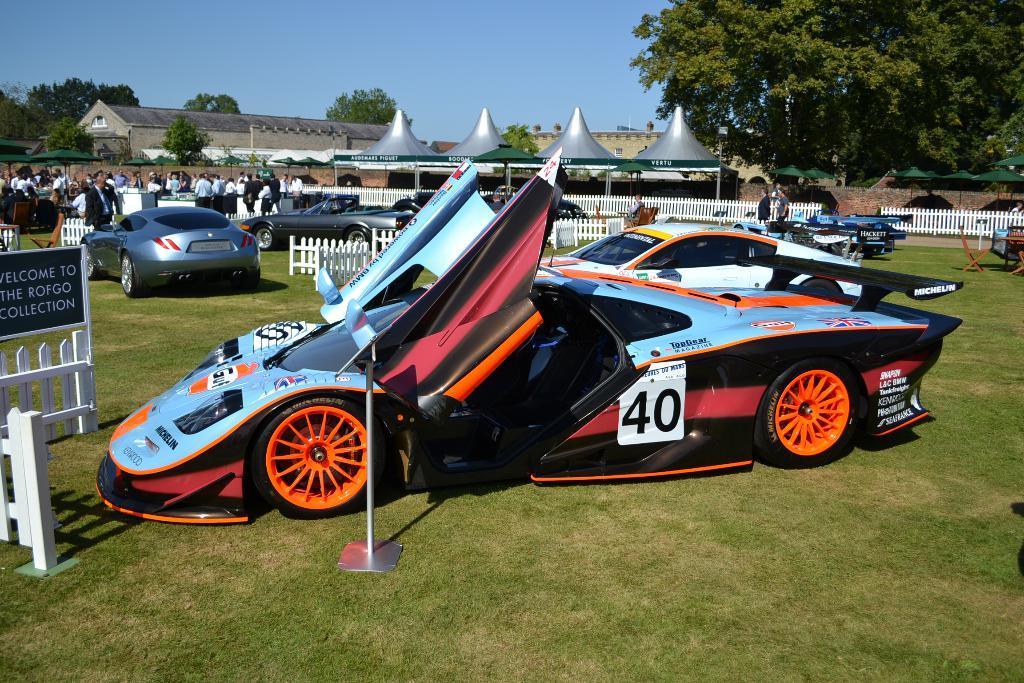Could you give a brief overview of what you see in this image? This image consists of a cars kept on the ground. At the bottom, there is green grass. To the left, there are many people. In the background, there is a fencing along with trees and sky. 